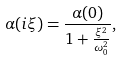<formula> <loc_0><loc_0><loc_500><loc_500>\alpha ( i \xi ) = \frac { \alpha ( 0 ) } { 1 + \frac { \xi ^ { 2 } } { \omega _ { 0 } ^ { 2 } } } ,</formula> 